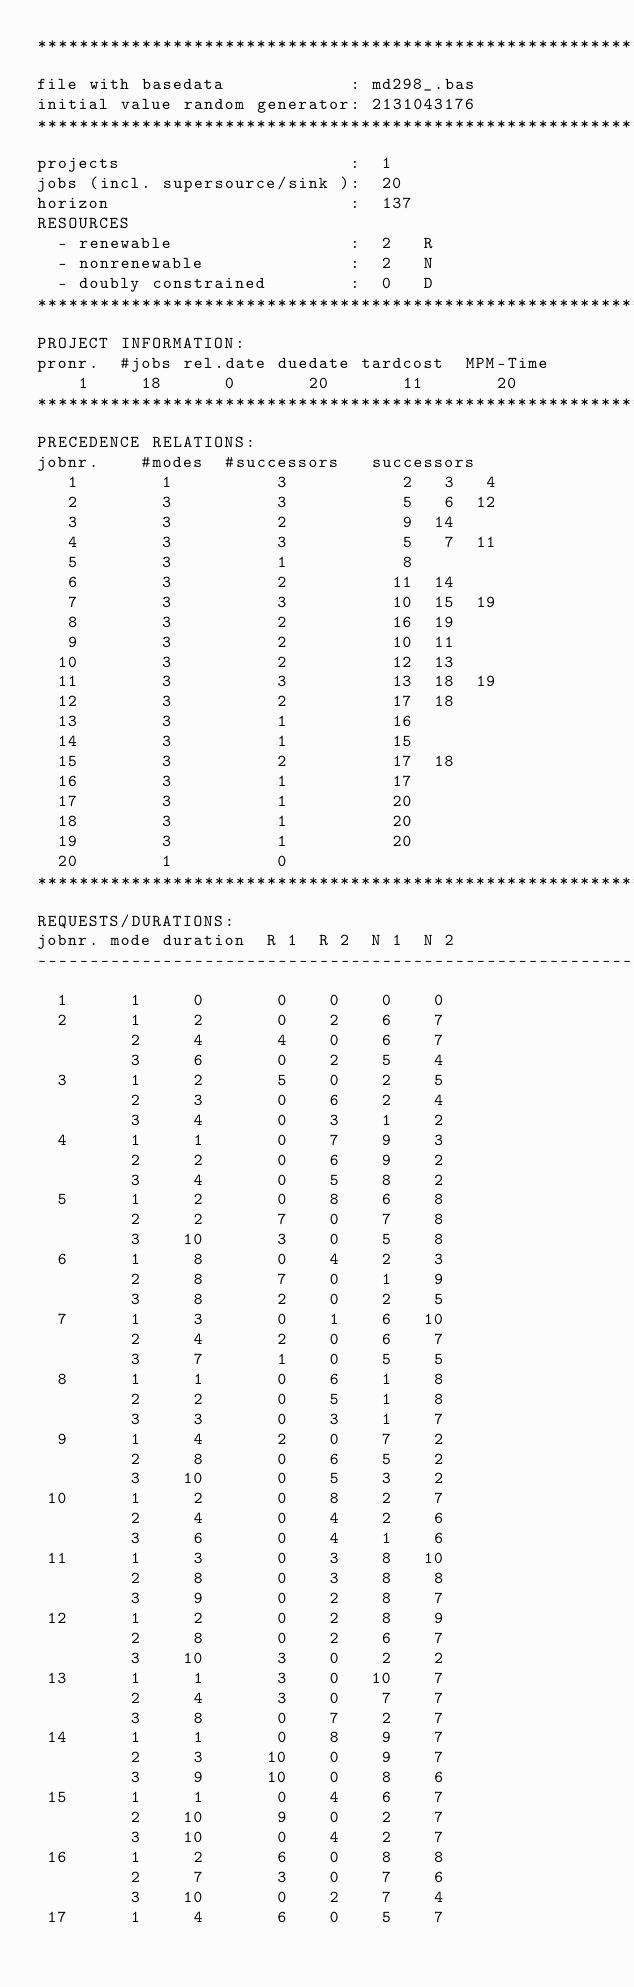<code> <loc_0><loc_0><loc_500><loc_500><_ObjectiveC_>************************************************************************
file with basedata            : md298_.bas
initial value random generator: 2131043176
************************************************************************
projects                      :  1
jobs (incl. supersource/sink ):  20
horizon                       :  137
RESOURCES
  - renewable                 :  2   R
  - nonrenewable              :  2   N
  - doubly constrained        :  0   D
************************************************************************
PROJECT INFORMATION:
pronr.  #jobs rel.date duedate tardcost  MPM-Time
    1     18      0       20       11       20
************************************************************************
PRECEDENCE RELATIONS:
jobnr.    #modes  #successors   successors
   1        1          3           2   3   4
   2        3          3           5   6  12
   3        3          2           9  14
   4        3          3           5   7  11
   5        3          1           8
   6        3          2          11  14
   7        3          3          10  15  19
   8        3          2          16  19
   9        3          2          10  11
  10        3          2          12  13
  11        3          3          13  18  19
  12        3          2          17  18
  13        3          1          16
  14        3          1          15
  15        3          2          17  18
  16        3          1          17
  17        3          1          20
  18        3          1          20
  19        3          1          20
  20        1          0        
************************************************************************
REQUESTS/DURATIONS:
jobnr. mode duration  R 1  R 2  N 1  N 2
------------------------------------------------------------------------
  1      1     0       0    0    0    0
  2      1     2       0    2    6    7
         2     4       4    0    6    7
         3     6       0    2    5    4
  3      1     2       5    0    2    5
         2     3       0    6    2    4
         3     4       0    3    1    2
  4      1     1       0    7    9    3
         2     2       0    6    9    2
         3     4       0    5    8    2
  5      1     2       0    8    6    8
         2     2       7    0    7    8
         3    10       3    0    5    8
  6      1     8       0    4    2    3
         2     8       7    0    1    9
         3     8       2    0    2    5
  7      1     3       0    1    6   10
         2     4       2    0    6    7
         3     7       1    0    5    5
  8      1     1       0    6    1    8
         2     2       0    5    1    8
         3     3       0    3    1    7
  9      1     4       2    0    7    2
         2     8       0    6    5    2
         3    10       0    5    3    2
 10      1     2       0    8    2    7
         2     4       0    4    2    6
         3     6       0    4    1    6
 11      1     3       0    3    8   10
         2     8       0    3    8    8
         3     9       0    2    8    7
 12      1     2       0    2    8    9
         2     8       0    2    6    7
         3    10       3    0    2    2
 13      1     1       3    0   10    7
         2     4       3    0    7    7
         3     8       0    7    2    7
 14      1     1       0    8    9    7
         2     3      10    0    9    7
         3     9      10    0    8    6
 15      1     1       0    4    6    7
         2    10       9    0    2    7
         3    10       0    4    2    7
 16      1     2       6    0    8    8
         2     7       3    0    7    6
         3    10       0    2    7    4
 17      1     4       6    0    5    7</code> 